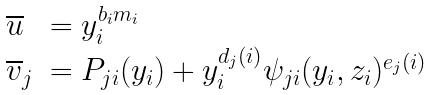<formula> <loc_0><loc_0><loc_500><loc_500>\begin{array} { l l } \overline { u } & = y _ { i } ^ { b _ { i } m _ { i } } \\ \overline { v } _ { j } & = P _ { j i } ( y _ { i } ) + y _ { i } ^ { d _ { j } ( i ) } \psi _ { j i } ( y _ { i } , z _ { i } ) ^ { e _ { j } ( i ) } \end{array}</formula> 